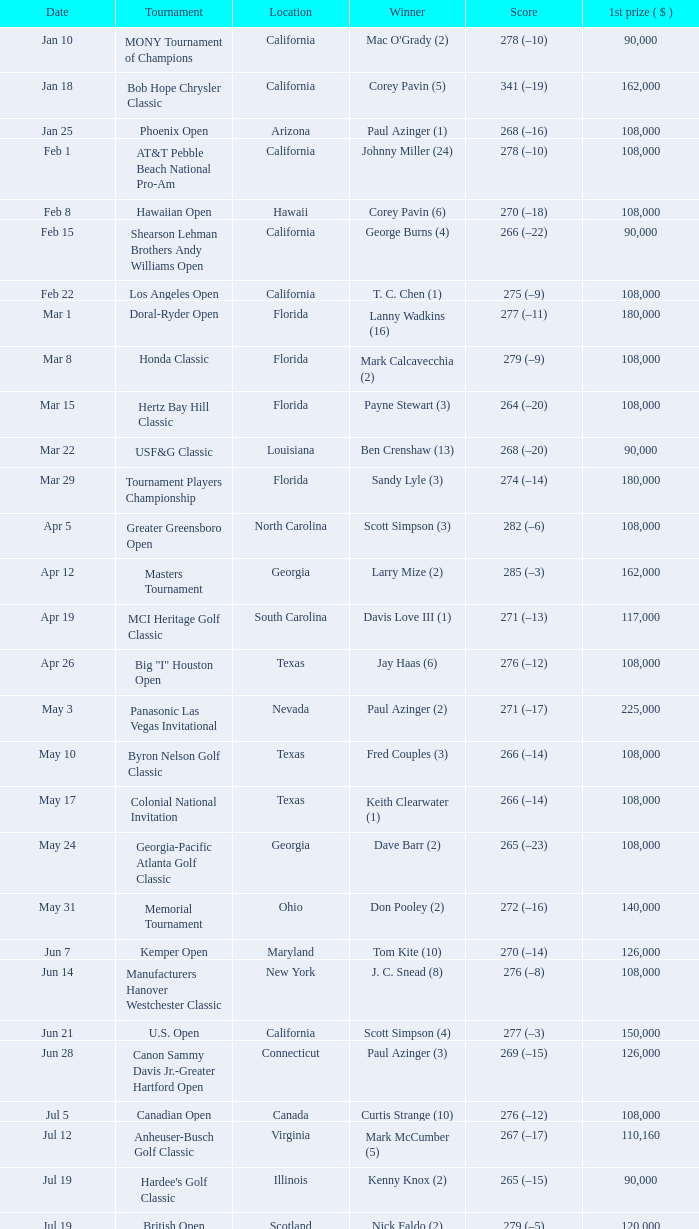What is the score from the winner Keith Clearwater (1)? 266 (–14). 